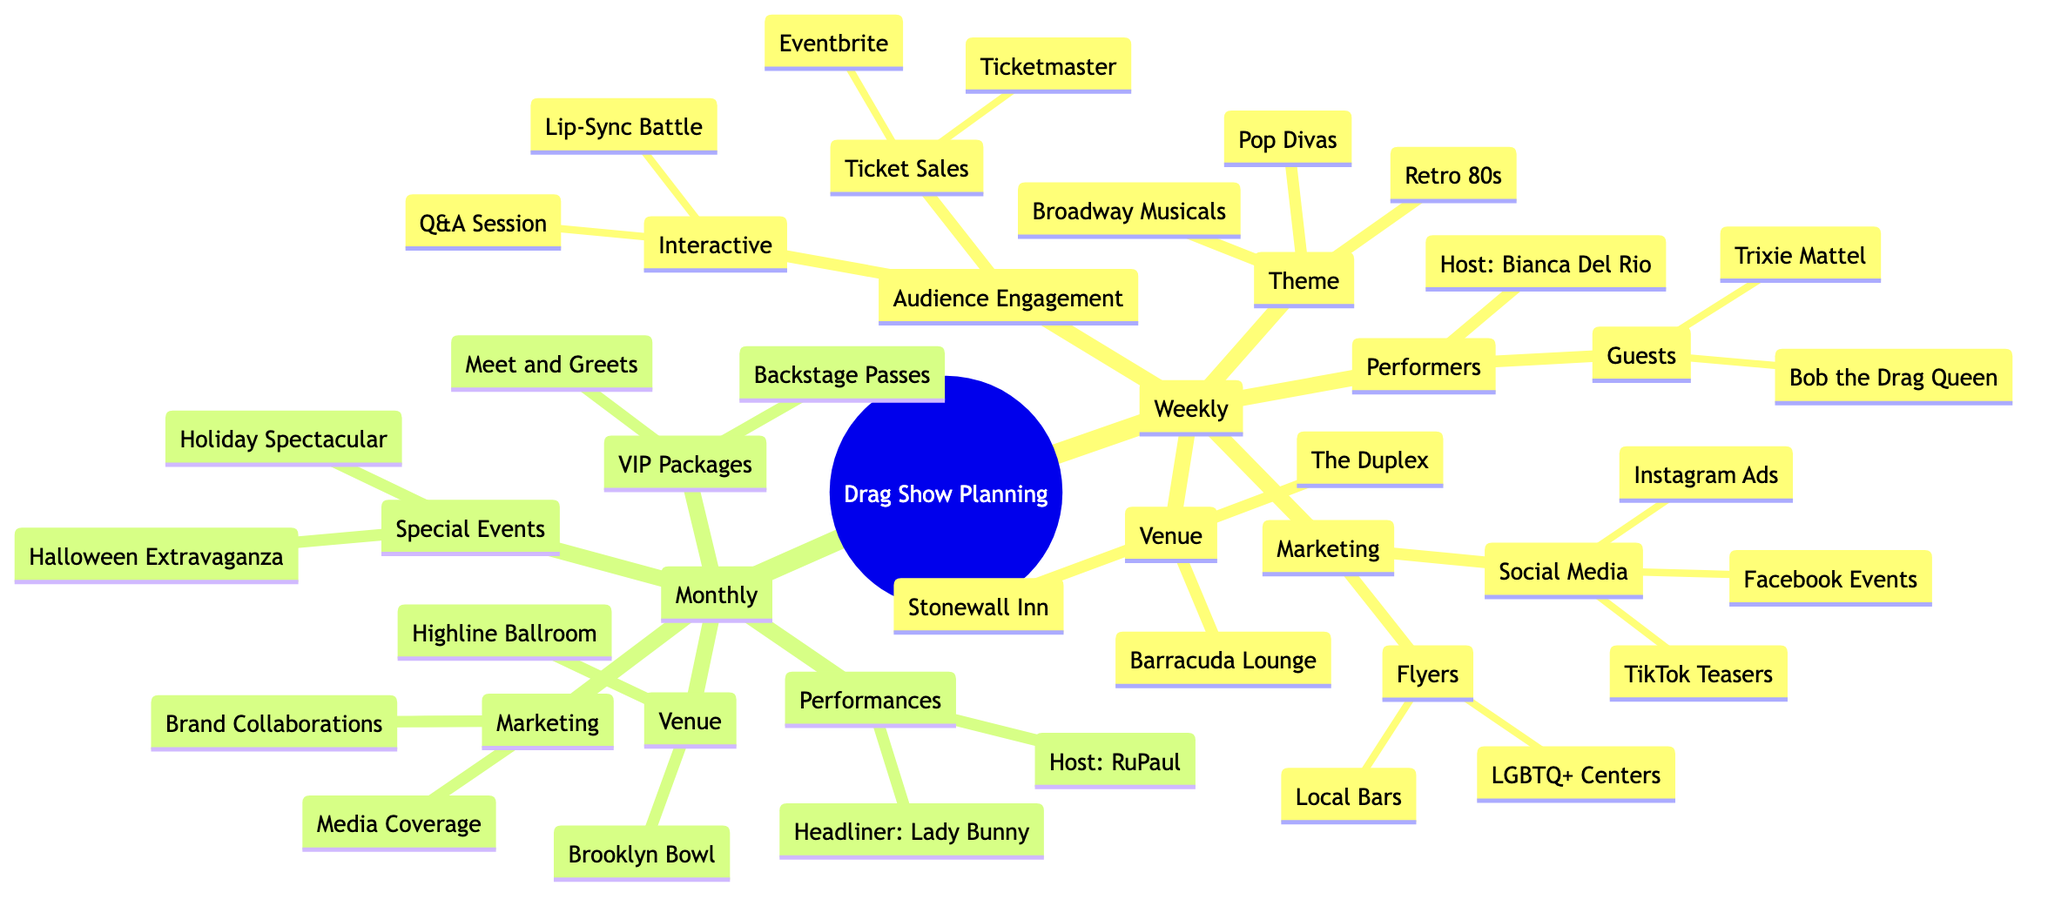What's the weekly theme for the drag show? The diagram lists three weekly themes under "Weekly Theme Selection": "Retro 80s," "Broadway Musicals," and "Pop Divas."
Answer: Retro 80s, Broadway Musicals, Pop Divas How many venues are listed for weekly shows? The section under "Venue Booking" mentions three specific venues: "Stonewall Inn," "The Duplex," and "Barracuda Lounge," indicating a count of three.
Answer: 3 Who is the host for the monthly drag show? The "Main Event Line-up" under monthly shows specifies that "Host: RuPaul" is listed as the host for the monthly show.
Answer: RuPaul What type of interactive segments can the audience expect at weekly shows? Under "Interactive Segments," the diagram lists two activities: "Audience Lip-Sync Battle" and "Drag Queen Q&A," which inform us about the engagement options.
Answer: Audience Lip-Sync Battle, Drag Queen Q&A What is one venue for monthly special events? The "Special Venue Booking" section mentions "Brooklyn Bowl" and "Highline Ballroom," providing at least one option that is designated for monthly events.
Answer: Brooklyn Bowl How many types of marketing activities are included in the weekly drag show planning? In the diagram, "Marketing and Promotion" is divided into three clear categories: "Social Media Campaigns," "Flyers and Posters," and "Partnerships," accounting for a total of three types of marketing activities.
Answer: 3 What are the two special performances mentioned for the monthly events? Under "Special Performances," the options listed are "Drag King Acts" and "Live Singing Numbers," showing two distinct types of performance planned for the monthly shows.
Answer: Drag King Acts, Live Singing Numbers What are the two platforms for ticket sales in weekly drag shows? The "Ticket Sales and Reservations" section notes two platforms: "Eventbrite" and "Ticketmaster," indicating where attendees can purchase tickets.
Answer: Eventbrite, Ticketmaster What is the main purpose of the VIP Ticket Packages? The "Advanced Audience Engagement" section lists the offerings for VIP packages as "Backstage Passes" and "Meet and Greets," highlighting their intent to enhance the audience experience.
Answer: Backstage Passes, Meet and Greets 